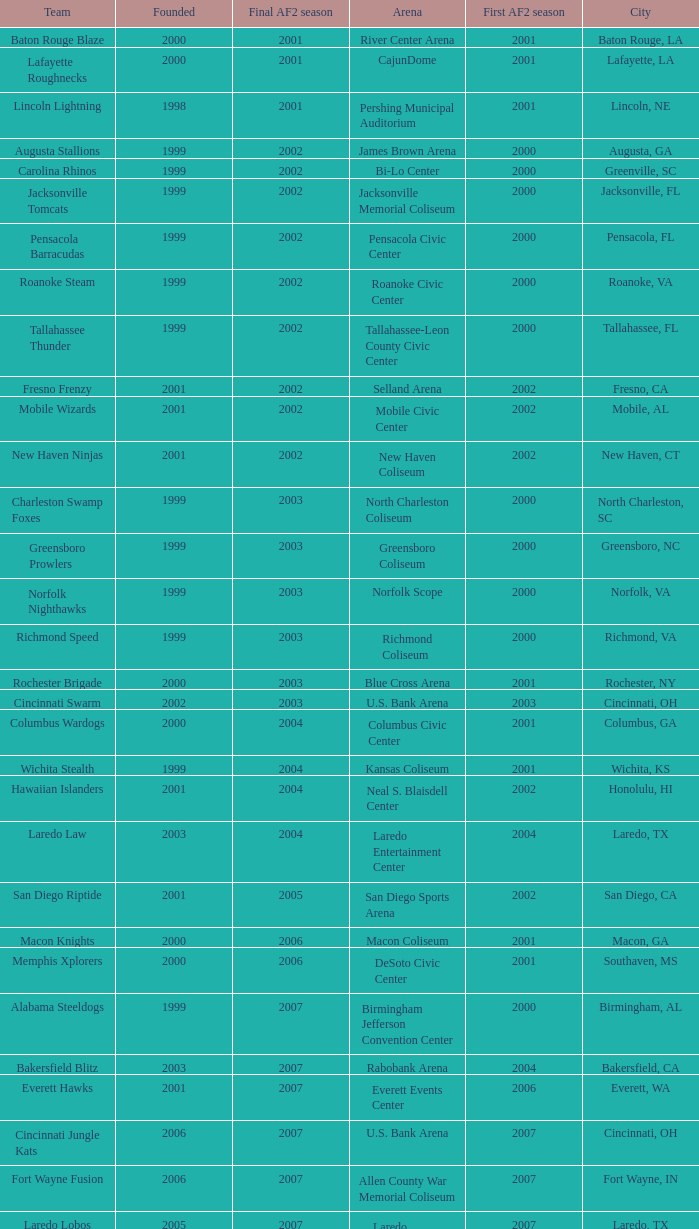Could you parse the entire table as a dict? {'header': ['Team', 'Founded', 'Final AF2 season', 'Arena', 'First AF2 season', 'City'], 'rows': [['Baton Rouge Blaze', '2000', '2001', 'River Center Arena', '2001', 'Baton Rouge, LA'], ['Lafayette Roughnecks', '2000', '2001', 'CajunDome', '2001', 'Lafayette, LA'], ['Lincoln Lightning', '1998', '2001', 'Pershing Municipal Auditorium', '2001', 'Lincoln, NE'], ['Augusta Stallions', '1999', '2002', 'James Brown Arena', '2000', 'Augusta, GA'], ['Carolina Rhinos', '1999', '2002', 'Bi-Lo Center', '2000', 'Greenville, SC'], ['Jacksonville Tomcats', '1999', '2002', 'Jacksonville Memorial Coliseum', '2000', 'Jacksonville, FL'], ['Pensacola Barracudas', '1999', '2002', 'Pensacola Civic Center', '2000', 'Pensacola, FL'], ['Roanoke Steam', '1999', '2002', 'Roanoke Civic Center', '2000', 'Roanoke, VA'], ['Tallahassee Thunder', '1999', '2002', 'Tallahassee-Leon County Civic Center', '2000', 'Tallahassee, FL'], ['Fresno Frenzy', '2001', '2002', 'Selland Arena', '2002', 'Fresno, CA'], ['Mobile Wizards', '2001', '2002', 'Mobile Civic Center', '2002', 'Mobile, AL'], ['New Haven Ninjas', '2001', '2002', 'New Haven Coliseum', '2002', 'New Haven, CT'], ['Charleston Swamp Foxes', '1999', '2003', 'North Charleston Coliseum', '2000', 'North Charleston, SC'], ['Greensboro Prowlers', '1999', '2003', 'Greensboro Coliseum', '2000', 'Greensboro, NC'], ['Norfolk Nighthawks', '1999', '2003', 'Norfolk Scope', '2000', 'Norfolk, VA'], ['Richmond Speed', '1999', '2003', 'Richmond Coliseum', '2000', 'Richmond, VA'], ['Rochester Brigade', '2000', '2003', 'Blue Cross Arena', '2001', 'Rochester, NY'], ['Cincinnati Swarm', '2002', '2003', 'U.S. Bank Arena', '2003', 'Cincinnati, OH'], ['Columbus Wardogs', '2000', '2004', 'Columbus Civic Center', '2001', 'Columbus, GA'], ['Wichita Stealth', '1999', '2004', 'Kansas Coliseum', '2001', 'Wichita, KS'], ['Hawaiian Islanders', '2001', '2004', 'Neal S. Blaisdell Center', '2002', 'Honolulu, HI'], ['Laredo Law', '2003', '2004', 'Laredo Entertainment Center', '2004', 'Laredo, TX'], ['San Diego Riptide', '2001', '2005', 'San Diego Sports Arena', '2002', 'San Diego, CA'], ['Macon Knights', '2000', '2006', 'Macon Coliseum', '2001', 'Macon, GA'], ['Memphis Xplorers', '2000', '2006', 'DeSoto Civic Center', '2001', 'Southaven, MS'], ['Alabama Steeldogs', '1999', '2007', 'Birmingham Jefferson Convention Center', '2000', 'Birmingham, AL'], ['Bakersfield Blitz', '2003', '2007', 'Rabobank Arena', '2004', 'Bakersfield, CA'], ['Everett Hawks', '2001', '2007', 'Everett Events Center', '2006', 'Everett, WA'], ['Cincinnati Jungle Kats', '2006', '2007', 'U.S. Bank Arena', '2007', 'Cincinnati, OH'], ['Fort Wayne Fusion', '2006', '2007', 'Allen County War Memorial Coliseum', '2007', 'Fort Wayne, IN'], ['Laredo Lobos', '2005', '2007', 'Laredo Entertainment Center', '2007', 'Laredo, TX'], ['Louisville Fire', '2000', '2008', 'Freedom Hall', '2001', 'Louisville, KY'], ['Lubbock Renegades', '2006', '2008', 'City Bank Coliseum', '2007', 'Lubbock, TX'], ['Texas Copperheads', '2005', '2008', 'Richard E. Berry Educational Support Center', '2007', 'Cypress, TX'], ['Austin Wranglers', '2003', '2008', 'Frank Erwin Center', '2008', 'Austin, TX'], ['Daytona Beach ThunderBirds', '2005', '2008', 'Ocean Center', '2008', 'Daytona Beach, FL'], ['Mahoning Valley Thunder', '2007', '2009', 'Covelli Centre', '2007', 'Youngstown, OH'], ['Arkansas Twisters', '1999', '2009', 'Verizon Arena', '2000', 'North Little Rock, Arkansas'], ['Central Valley Coyotes', '2001', '2009', 'Selland Arena', '2002', 'Fresno, California'], ['Kentucky Horsemen', '2002', '2009', 'Rupp Arena', '2008', 'Lexington, Kentucky'], ['Tri-Cities Fever', '2004', '2009', 'Toyota Center', '2007', 'Kennewick, Washington']]} How many founded years had a final af2 season prior to 2009 where the arena was the bi-lo center and the first af2 season was prior to 2000? 0.0. 